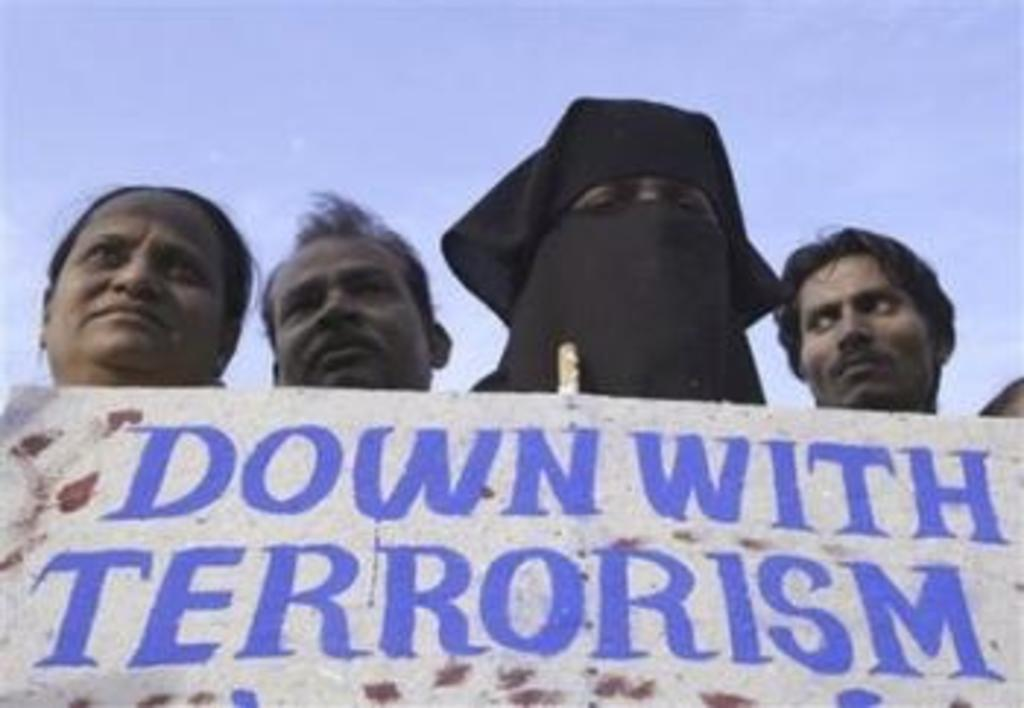How many women are in the image? There are two women in the image. Are there any men in the image? Yes, there is at least one man in the image. What are the individuals standing behind in the image? The individuals are standing behind a banner. What can be seen above the banner in the image? The sky is visible above the banner. Can you tell me how many rats are sitting on the banner in the image? There are no rats present on the banner or in the image. What type of ticket is being sold at the event in the image? There is no event or ticket mentioned or depicted in the image. 